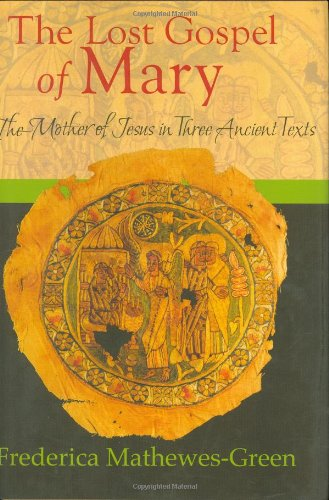What is the title of this book? The title of the book depicted in the image is 'The Lost Gospel of Mary: The Mother of Jesus in Three Ancient Texts'. It’s a detailed exploration into texts related to Mary, the mother of Jesus. 